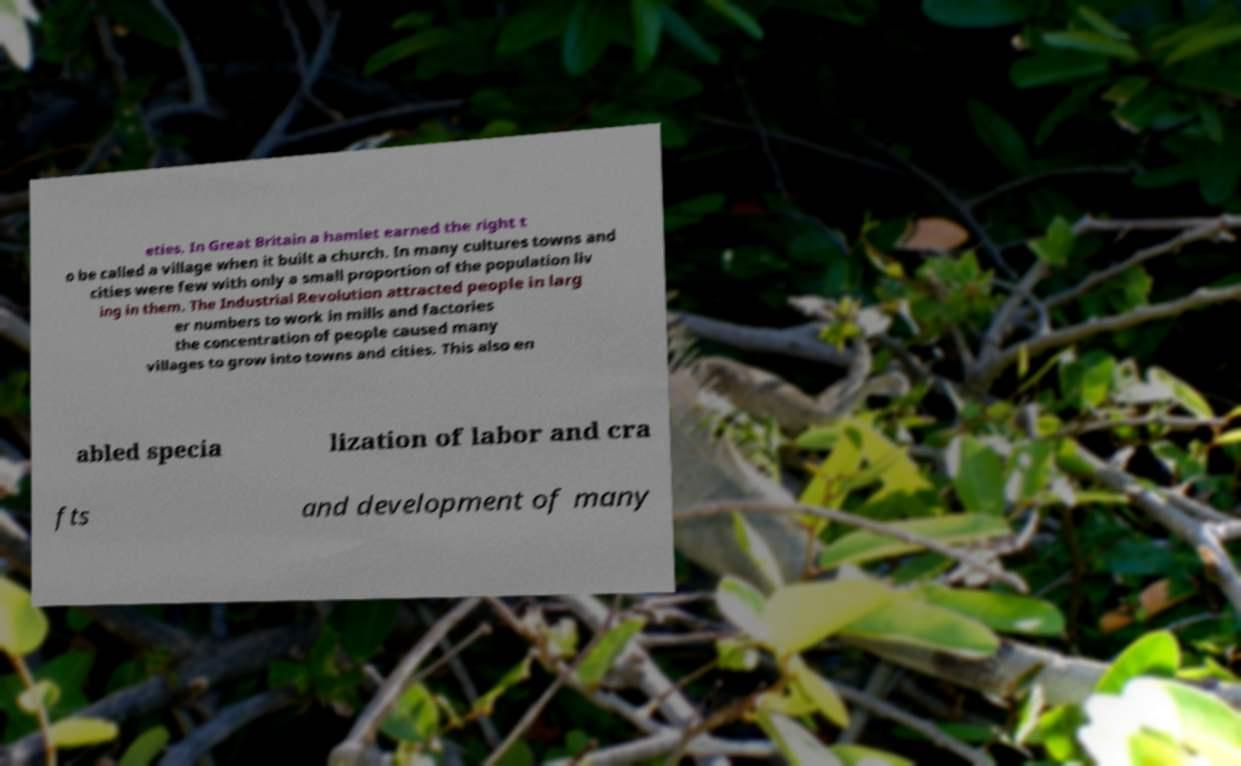Could you extract and type out the text from this image? eties. In Great Britain a hamlet earned the right t o be called a village when it built a church. In many cultures towns and cities were few with only a small proportion of the population liv ing in them. The Industrial Revolution attracted people in larg er numbers to work in mills and factories the concentration of people caused many villages to grow into towns and cities. This also en abled specia lization of labor and cra fts and development of many 